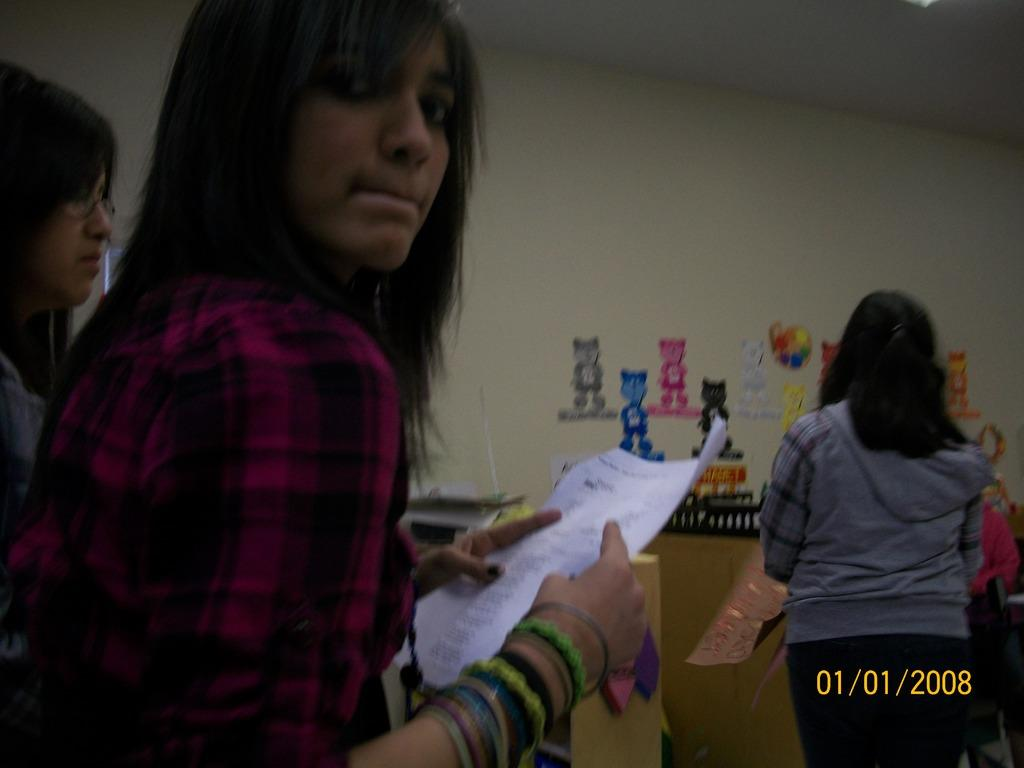<image>
Give a short and clear explanation of the subsequent image. The line only contained three people on 01/01/2008. 